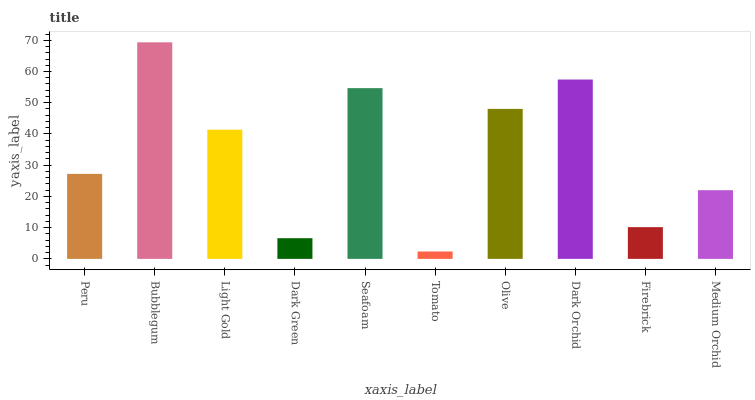Is Tomato the minimum?
Answer yes or no. Yes. Is Bubblegum the maximum?
Answer yes or no. Yes. Is Light Gold the minimum?
Answer yes or no. No. Is Light Gold the maximum?
Answer yes or no. No. Is Bubblegum greater than Light Gold?
Answer yes or no. Yes. Is Light Gold less than Bubblegum?
Answer yes or no. Yes. Is Light Gold greater than Bubblegum?
Answer yes or no. No. Is Bubblegum less than Light Gold?
Answer yes or no. No. Is Light Gold the high median?
Answer yes or no. Yes. Is Peru the low median?
Answer yes or no. Yes. Is Firebrick the high median?
Answer yes or no. No. Is Seafoam the low median?
Answer yes or no. No. 